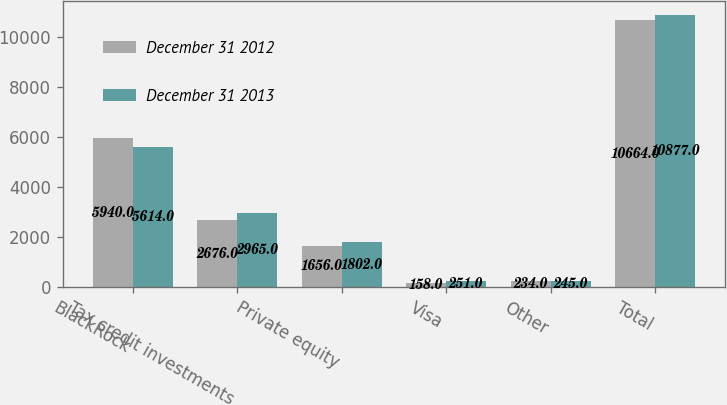Convert chart to OTSL. <chart><loc_0><loc_0><loc_500><loc_500><stacked_bar_chart><ecel><fcel>BlackRock<fcel>Tax credit investments<fcel>Private equity<fcel>Visa<fcel>Other<fcel>Total<nl><fcel>December 31 2012<fcel>5940<fcel>2676<fcel>1656<fcel>158<fcel>234<fcel>10664<nl><fcel>December 31 2013<fcel>5614<fcel>2965<fcel>1802<fcel>251<fcel>245<fcel>10877<nl></chart> 